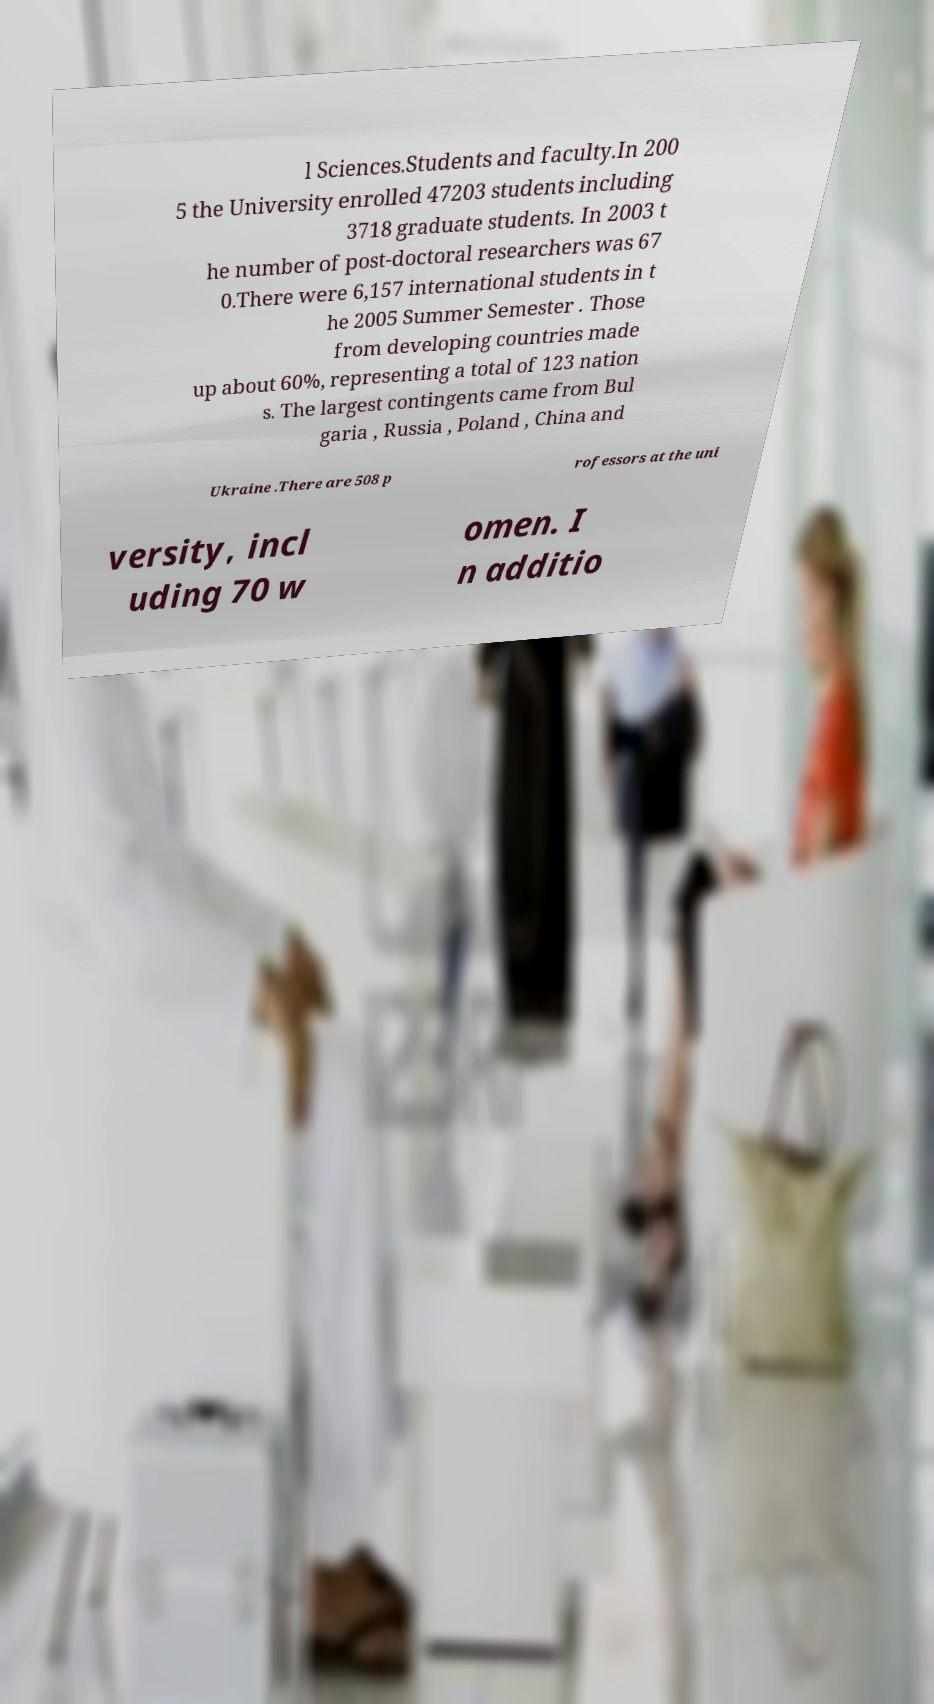What messages or text are displayed in this image? I need them in a readable, typed format. l Sciences.Students and faculty.In 200 5 the University enrolled 47203 students including 3718 graduate students. In 2003 t he number of post-doctoral researchers was 67 0.There were 6,157 international students in t he 2005 Summer Semester . Those from developing countries made up about 60%, representing a total of 123 nation s. The largest contingents came from Bul garia , Russia , Poland , China and Ukraine .There are 508 p rofessors at the uni versity, incl uding 70 w omen. I n additio 